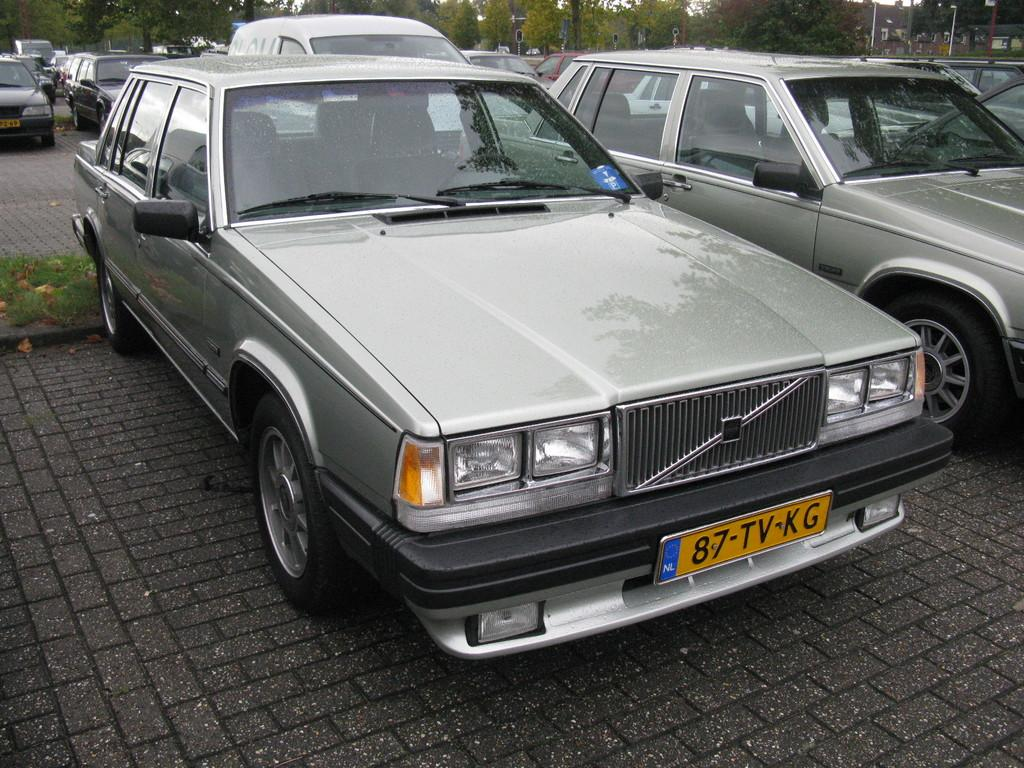What can be seen in the image related to vehicles? There are cars parked in the image. Where are the cars located? The cars are in a parking lot. What can be seen in the background of the image? There are trees in the background of the image. What type of reaction does the cook have when they see the cup in the image? There is no cook or cup present in the image, so it is not possible to answer that question. 